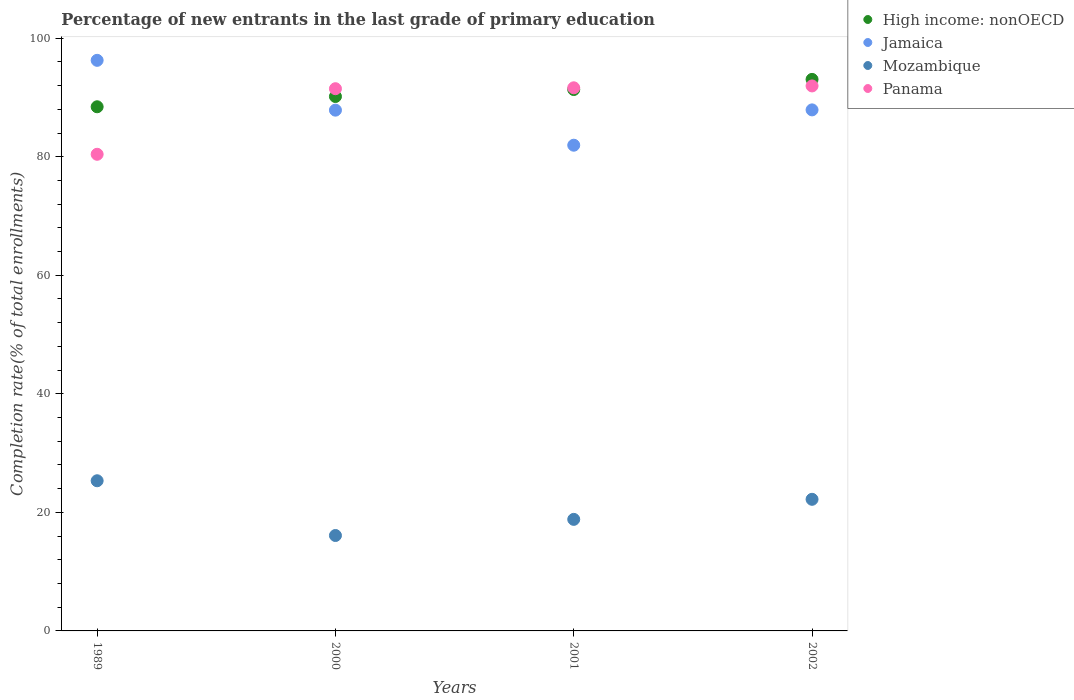How many different coloured dotlines are there?
Make the answer very short. 4. What is the percentage of new entrants in Panama in 1989?
Your response must be concise. 80.41. Across all years, what is the maximum percentage of new entrants in Mozambique?
Provide a short and direct response. 25.33. Across all years, what is the minimum percentage of new entrants in Mozambique?
Give a very brief answer. 16.1. In which year was the percentage of new entrants in High income: nonOECD maximum?
Your answer should be compact. 2002. In which year was the percentage of new entrants in Jamaica minimum?
Offer a very short reply. 2001. What is the total percentage of new entrants in High income: nonOECD in the graph?
Offer a very short reply. 362.98. What is the difference between the percentage of new entrants in Panama in 1989 and that in 2001?
Keep it short and to the point. -11.22. What is the difference between the percentage of new entrants in Panama in 1989 and the percentage of new entrants in Jamaica in 2000?
Your response must be concise. -7.45. What is the average percentage of new entrants in Panama per year?
Provide a succinct answer. 88.87. In the year 2000, what is the difference between the percentage of new entrants in Mozambique and percentage of new entrants in Jamaica?
Provide a short and direct response. -71.76. What is the ratio of the percentage of new entrants in Mozambique in 2001 to that in 2002?
Provide a short and direct response. 0.85. Is the percentage of new entrants in Panama in 2001 less than that in 2002?
Your answer should be compact. Yes. Is the difference between the percentage of new entrants in Mozambique in 2000 and 2002 greater than the difference between the percentage of new entrants in Jamaica in 2000 and 2002?
Your response must be concise. No. What is the difference between the highest and the second highest percentage of new entrants in Panama?
Give a very brief answer. 0.32. What is the difference between the highest and the lowest percentage of new entrants in Jamaica?
Keep it short and to the point. 14.32. In how many years, is the percentage of new entrants in Jamaica greater than the average percentage of new entrants in Jamaica taken over all years?
Ensure brevity in your answer.  1. Is it the case that in every year, the sum of the percentage of new entrants in High income: nonOECD and percentage of new entrants in Jamaica  is greater than the sum of percentage of new entrants in Panama and percentage of new entrants in Mozambique?
Your answer should be compact. No. Is it the case that in every year, the sum of the percentage of new entrants in Mozambique and percentage of new entrants in Jamaica  is greater than the percentage of new entrants in Panama?
Provide a short and direct response. Yes. Does the percentage of new entrants in High income: nonOECD monotonically increase over the years?
Your answer should be very brief. Yes. Is the percentage of new entrants in Mozambique strictly less than the percentage of new entrants in Panama over the years?
Provide a succinct answer. Yes. How many dotlines are there?
Your response must be concise. 4. How many years are there in the graph?
Provide a succinct answer. 4. Are the values on the major ticks of Y-axis written in scientific E-notation?
Offer a terse response. No. Where does the legend appear in the graph?
Offer a terse response. Top right. What is the title of the graph?
Offer a terse response. Percentage of new entrants in the last grade of primary education. What is the label or title of the Y-axis?
Provide a short and direct response. Completion rate(% of total enrollments). What is the Completion rate(% of total enrollments) of High income: nonOECD in 1989?
Your response must be concise. 88.43. What is the Completion rate(% of total enrollments) in Jamaica in 1989?
Provide a short and direct response. 96.26. What is the Completion rate(% of total enrollments) in Mozambique in 1989?
Your answer should be very brief. 25.33. What is the Completion rate(% of total enrollments) in Panama in 1989?
Your answer should be very brief. 80.41. What is the Completion rate(% of total enrollments) in High income: nonOECD in 2000?
Make the answer very short. 90.16. What is the Completion rate(% of total enrollments) of Jamaica in 2000?
Keep it short and to the point. 87.86. What is the Completion rate(% of total enrollments) in Mozambique in 2000?
Your response must be concise. 16.1. What is the Completion rate(% of total enrollments) of Panama in 2000?
Ensure brevity in your answer.  91.48. What is the Completion rate(% of total enrollments) of High income: nonOECD in 2001?
Your answer should be very brief. 91.34. What is the Completion rate(% of total enrollments) in Jamaica in 2001?
Your answer should be very brief. 81.95. What is the Completion rate(% of total enrollments) in Mozambique in 2001?
Make the answer very short. 18.82. What is the Completion rate(% of total enrollments) of Panama in 2001?
Provide a succinct answer. 91.63. What is the Completion rate(% of total enrollments) in High income: nonOECD in 2002?
Your answer should be very brief. 93.05. What is the Completion rate(% of total enrollments) in Jamaica in 2002?
Offer a very short reply. 87.91. What is the Completion rate(% of total enrollments) of Mozambique in 2002?
Offer a very short reply. 22.2. What is the Completion rate(% of total enrollments) of Panama in 2002?
Your answer should be compact. 91.95. Across all years, what is the maximum Completion rate(% of total enrollments) of High income: nonOECD?
Your answer should be compact. 93.05. Across all years, what is the maximum Completion rate(% of total enrollments) of Jamaica?
Provide a succinct answer. 96.26. Across all years, what is the maximum Completion rate(% of total enrollments) of Mozambique?
Provide a succinct answer. 25.33. Across all years, what is the maximum Completion rate(% of total enrollments) in Panama?
Your response must be concise. 91.95. Across all years, what is the minimum Completion rate(% of total enrollments) of High income: nonOECD?
Offer a terse response. 88.43. Across all years, what is the minimum Completion rate(% of total enrollments) in Jamaica?
Ensure brevity in your answer.  81.95. Across all years, what is the minimum Completion rate(% of total enrollments) of Mozambique?
Provide a succinct answer. 16.1. Across all years, what is the minimum Completion rate(% of total enrollments) of Panama?
Offer a terse response. 80.41. What is the total Completion rate(% of total enrollments) of High income: nonOECD in the graph?
Ensure brevity in your answer.  362.98. What is the total Completion rate(% of total enrollments) of Jamaica in the graph?
Give a very brief answer. 353.97. What is the total Completion rate(% of total enrollments) in Mozambique in the graph?
Offer a terse response. 82.46. What is the total Completion rate(% of total enrollments) in Panama in the graph?
Make the answer very short. 355.47. What is the difference between the Completion rate(% of total enrollments) of High income: nonOECD in 1989 and that in 2000?
Ensure brevity in your answer.  -1.73. What is the difference between the Completion rate(% of total enrollments) in Jamaica in 1989 and that in 2000?
Your answer should be compact. 8.4. What is the difference between the Completion rate(% of total enrollments) in Mozambique in 1989 and that in 2000?
Your answer should be very brief. 9.24. What is the difference between the Completion rate(% of total enrollments) of Panama in 1989 and that in 2000?
Your answer should be very brief. -11.06. What is the difference between the Completion rate(% of total enrollments) of High income: nonOECD in 1989 and that in 2001?
Offer a terse response. -2.91. What is the difference between the Completion rate(% of total enrollments) of Jamaica in 1989 and that in 2001?
Your response must be concise. 14.32. What is the difference between the Completion rate(% of total enrollments) of Mozambique in 1989 and that in 2001?
Offer a terse response. 6.51. What is the difference between the Completion rate(% of total enrollments) in Panama in 1989 and that in 2001?
Provide a succinct answer. -11.22. What is the difference between the Completion rate(% of total enrollments) of High income: nonOECD in 1989 and that in 2002?
Your answer should be compact. -4.62. What is the difference between the Completion rate(% of total enrollments) in Jamaica in 1989 and that in 2002?
Provide a succinct answer. 8.36. What is the difference between the Completion rate(% of total enrollments) in Mozambique in 1989 and that in 2002?
Offer a terse response. 3.13. What is the difference between the Completion rate(% of total enrollments) in Panama in 1989 and that in 2002?
Ensure brevity in your answer.  -11.53. What is the difference between the Completion rate(% of total enrollments) in High income: nonOECD in 2000 and that in 2001?
Offer a terse response. -1.18. What is the difference between the Completion rate(% of total enrollments) of Jamaica in 2000 and that in 2001?
Provide a short and direct response. 5.91. What is the difference between the Completion rate(% of total enrollments) of Mozambique in 2000 and that in 2001?
Provide a short and direct response. -2.72. What is the difference between the Completion rate(% of total enrollments) in Panama in 2000 and that in 2001?
Your response must be concise. -0.15. What is the difference between the Completion rate(% of total enrollments) of High income: nonOECD in 2000 and that in 2002?
Make the answer very short. -2.89. What is the difference between the Completion rate(% of total enrollments) in Jamaica in 2000 and that in 2002?
Your answer should be compact. -0.05. What is the difference between the Completion rate(% of total enrollments) of Mozambique in 2000 and that in 2002?
Provide a short and direct response. -6.11. What is the difference between the Completion rate(% of total enrollments) of Panama in 2000 and that in 2002?
Ensure brevity in your answer.  -0.47. What is the difference between the Completion rate(% of total enrollments) of High income: nonOECD in 2001 and that in 2002?
Give a very brief answer. -1.71. What is the difference between the Completion rate(% of total enrollments) of Jamaica in 2001 and that in 2002?
Your answer should be very brief. -5.96. What is the difference between the Completion rate(% of total enrollments) in Mozambique in 2001 and that in 2002?
Keep it short and to the point. -3.38. What is the difference between the Completion rate(% of total enrollments) of Panama in 2001 and that in 2002?
Provide a short and direct response. -0.32. What is the difference between the Completion rate(% of total enrollments) of High income: nonOECD in 1989 and the Completion rate(% of total enrollments) of Jamaica in 2000?
Provide a short and direct response. 0.57. What is the difference between the Completion rate(% of total enrollments) of High income: nonOECD in 1989 and the Completion rate(% of total enrollments) of Mozambique in 2000?
Make the answer very short. 72.33. What is the difference between the Completion rate(% of total enrollments) in High income: nonOECD in 1989 and the Completion rate(% of total enrollments) in Panama in 2000?
Give a very brief answer. -3.05. What is the difference between the Completion rate(% of total enrollments) of Jamaica in 1989 and the Completion rate(% of total enrollments) of Mozambique in 2000?
Provide a succinct answer. 80.17. What is the difference between the Completion rate(% of total enrollments) of Jamaica in 1989 and the Completion rate(% of total enrollments) of Panama in 2000?
Your answer should be very brief. 4.79. What is the difference between the Completion rate(% of total enrollments) in Mozambique in 1989 and the Completion rate(% of total enrollments) in Panama in 2000?
Your answer should be very brief. -66.14. What is the difference between the Completion rate(% of total enrollments) in High income: nonOECD in 1989 and the Completion rate(% of total enrollments) in Jamaica in 2001?
Your answer should be very brief. 6.48. What is the difference between the Completion rate(% of total enrollments) in High income: nonOECD in 1989 and the Completion rate(% of total enrollments) in Mozambique in 2001?
Offer a very short reply. 69.61. What is the difference between the Completion rate(% of total enrollments) in High income: nonOECD in 1989 and the Completion rate(% of total enrollments) in Panama in 2001?
Provide a short and direct response. -3.2. What is the difference between the Completion rate(% of total enrollments) of Jamaica in 1989 and the Completion rate(% of total enrollments) of Mozambique in 2001?
Provide a short and direct response. 77.45. What is the difference between the Completion rate(% of total enrollments) of Jamaica in 1989 and the Completion rate(% of total enrollments) of Panama in 2001?
Your answer should be very brief. 4.63. What is the difference between the Completion rate(% of total enrollments) of Mozambique in 1989 and the Completion rate(% of total enrollments) of Panama in 2001?
Ensure brevity in your answer.  -66.3. What is the difference between the Completion rate(% of total enrollments) in High income: nonOECD in 1989 and the Completion rate(% of total enrollments) in Jamaica in 2002?
Keep it short and to the point. 0.52. What is the difference between the Completion rate(% of total enrollments) of High income: nonOECD in 1989 and the Completion rate(% of total enrollments) of Mozambique in 2002?
Your answer should be compact. 66.23. What is the difference between the Completion rate(% of total enrollments) in High income: nonOECD in 1989 and the Completion rate(% of total enrollments) in Panama in 2002?
Give a very brief answer. -3.52. What is the difference between the Completion rate(% of total enrollments) of Jamaica in 1989 and the Completion rate(% of total enrollments) of Mozambique in 2002?
Keep it short and to the point. 74.06. What is the difference between the Completion rate(% of total enrollments) in Jamaica in 1989 and the Completion rate(% of total enrollments) in Panama in 2002?
Your answer should be very brief. 4.32. What is the difference between the Completion rate(% of total enrollments) of Mozambique in 1989 and the Completion rate(% of total enrollments) of Panama in 2002?
Keep it short and to the point. -66.61. What is the difference between the Completion rate(% of total enrollments) in High income: nonOECD in 2000 and the Completion rate(% of total enrollments) in Jamaica in 2001?
Your answer should be very brief. 8.22. What is the difference between the Completion rate(% of total enrollments) in High income: nonOECD in 2000 and the Completion rate(% of total enrollments) in Mozambique in 2001?
Offer a terse response. 71.34. What is the difference between the Completion rate(% of total enrollments) in High income: nonOECD in 2000 and the Completion rate(% of total enrollments) in Panama in 2001?
Give a very brief answer. -1.47. What is the difference between the Completion rate(% of total enrollments) in Jamaica in 2000 and the Completion rate(% of total enrollments) in Mozambique in 2001?
Your answer should be very brief. 69.04. What is the difference between the Completion rate(% of total enrollments) in Jamaica in 2000 and the Completion rate(% of total enrollments) in Panama in 2001?
Provide a succinct answer. -3.77. What is the difference between the Completion rate(% of total enrollments) of Mozambique in 2000 and the Completion rate(% of total enrollments) of Panama in 2001?
Keep it short and to the point. -75.53. What is the difference between the Completion rate(% of total enrollments) in High income: nonOECD in 2000 and the Completion rate(% of total enrollments) in Jamaica in 2002?
Your answer should be very brief. 2.26. What is the difference between the Completion rate(% of total enrollments) in High income: nonOECD in 2000 and the Completion rate(% of total enrollments) in Mozambique in 2002?
Offer a terse response. 67.96. What is the difference between the Completion rate(% of total enrollments) of High income: nonOECD in 2000 and the Completion rate(% of total enrollments) of Panama in 2002?
Make the answer very short. -1.78. What is the difference between the Completion rate(% of total enrollments) of Jamaica in 2000 and the Completion rate(% of total enrollments) of Mozambique in 2002?
Your answer should be compact. 65.66. What is the difference between the Completion rate(% of total enrollments) of Jamaica in 2000 and the Completion rate(% of total enrollments) of Panama in 2002?
Provide a succinct answer. -4.09. What is the difference between the Completion rate(% of total enrollments) in Mozambique in 2000 and the Completion rate(% of total enrollments) in Panama in 2002?
Offer a terse response. -75.85. What is the difference between the Completion rate(% of total enrollments) in High income: nonOECD in 2001 and the Completion rate(% of total enrollments) in Jamaica in 2002?
Provide a succinct answer. 3.43. What is the difference between the Completion rate(% of total enrollments) of High income: nonOECD in 2001 and the Completion rate(% of total enrollments) of Mozambique in 2002?
Give a very brief answer. 69.13. What is the difference between the Completion rate(% of total enrollments) of High income: nonOECD in 2001 and the Completion rate(% of total enrollments) of Panama in 2002?
Your response must be concise. -0.61. What is the difference between the Completion rate(% of total enrollments) of Jamaica in 2001 and the Completion rate(% of total enrollments) of Mozambique in 2002?
Your answer should be compact. 59.74. What is the difference between the Completion rate(% of total enrollments) in Jamaica in 2001 and the Completion rate(% of total enrollments) in Panama in 2002?
Your answer should be compact. -10. What is the difference between the Completion rate(% of total enrollments) in Mozambique in 2001 and the Completion rate(% of total enrollments) in Panama in 2002?
Your response must be concise. -73.13. What is the average Completion rate(% of total enrollments) in High income: nonOECD per year?
Provide a short and direct response. 90.74. What is the average Completion rate(% of total enrollments) in Jamaica per year?
Offer a very short reply. 88.49. What is the average Completion rate(% of total enrollments) of Mozambique per year?
Provide a succinct answer. 20.61. What is the average Completion rate(% of total enrollments) of Panama per year?
Offer a very short reply. 88.87. In the year 1989, what is the difference between the Completion rate(% of total enrollments) of High income: nonOECD and Completion rate(% of total enrollments) of Jamaica?
Your answer should be very brief. -7.84. In the year 1989, what is the difference between the Completion rate(% of total enrollments) of High income: nonOECD and Completion rate(% of total enrollments) of Mozambique?
Your answer should be very brief. 63.09. In the year 1989, what is the difference between the Completion rate(% of total enrollments) of High income: nonOECD and Completion rate(% of total enrollments) of Panama?
Your response must be concise. 8.02. In the year 1989, what is the difference between the Completion rate(% of total enrollments) of Jamaica and Completion rate(% of total enrollments) of Mozambique?
Keep it short and to the point. 70.93. In the year 1989, what is the difference between the Completion rate(% of total enrollments) in Jamaica and Completion rate(% of total enrollments) in Panama?
Your response must be concise. 15.85. In the year 1989, what is the difference between the Completion rate(% of total enrollments) in Mozambique and Completion rate(% of total enrollments) in Panama?
Offer a very short reply. -55.08. In the year 2000, what is the difference between the Completion rate(% of total enrollments) in High income: nonOECD and Completion rate(% of total enrollments) in Jamaica?
Keep it short and to the point. 2.3. In the year 2000, what is the difference between the Completion rate(% of total enrollments) in High income: nonOECD and Completion rate(% of total enrollments) in Mozambique?
Offer a very short reply. 74.06. In the year 2000, what is the difference between the Completion rate(% of total enrollments) in High income: nonOECD and Completion rate(% of total enrollments) in Panama?
Offer a very short reply. -1.32. In the year 2000, what is the difference between the Completion rate(% of total enrollments) of Jamaica and Completion rate(% of total enrollments) of Mozambique?
Make the answer very short. 71.76. In the year 2000, what is the difference between the Completion rate(% of total enrollments) of Jamaica and Completion rate(% of total enrollments) of Panama?
Give a very brief answer. -3.62. In the year 2000, what is the difference between the Completion rate(% of total enrollments) in Mozambique and Completion rate(% of total enrollments) in Panama?
Offer a terse response. -75.38. In the year 2001, what is the difference between the Completion rate(% of total enrollments) of High income: nonOECD and Completion rate(% of total enrollments) of Jamaica?
Make the answer very short. 9.39. In the year 2001, what is the difference between the Completion rate(% of total enrollments) in High income: nonOECD and Completion rate(% of total enrollments) in Mozambique?
Provide a short and direct response. 72.52. In the year 2001, what is the difference between the Completion rate(% of total enrollments) of High income: nonOECD and Completion rate(% of total enrollments) of Panama?
Ensure brevity in your answer.  -0.29. In the year 2001, what is the difference between the Completion rate(% of total enrollments) in Jamaica and Completion rate(% of total enrollments) in Mozambique?
Give a very brief answer. 63.13. In the year 2001, what is the difference between the Completion rate(% of total enrollments) in Jamaica and Completion rate(% of total enrollments) in Panama?
Your response must be concise. -9.69. In the year 2001, what is the difference between the Completion rate(% of total enrollments) in Mozambique and Completion rate(% of total enrollments) in Panama?
Ensure brevity in your answer.  -72.81. In the year 2002, what is the difference between the Completion rate(% of total enrollments) of High income: nonOECD and Completion rate(% of total enrollments) of Jamaica?
Make the answer very short. 5.14. In the year 2002, what is the difference between the Completion rate(% of total enrollments) of High income: nonOECD and Completion rate(% of total enrollments) of Mozambique?
Provide a short and direct response. 70.84. In the year 2002, what is the difference between the Completion rate(% of total enrollments) of High income: nonOECD and Completion rate(% of total enrollments) of Panama?
Provide a succinct answer. 1.1. In the year 2002, what is the difference between the Completion rate(% of total enrollments) in Jamaica and Completion rate(% of total enrollments) in Mozambique?
Keep it short and to the point. 65.7. In the year 2002, what is the difference between the Completion rate(% of total enrollments) in Jamaica and Completion rate(% of total enrollments) in Panama?
Give a very brief answer. -4.04. In the year 2002, what is the difference between the Completion rate(% of total enrollments) in Mozambique and Completion rate(% of total enrollments) in Panama?
Provide a succinct answer. -69.74. What is the ratio of the Completion rate(% of total enrollments) in High income: nonOECD in 1989 to that in 2000?
Your answer should be compact. 0.98. What is the ratio of the Completion rate(% of total enrollments) of Jamaica in 1989 to that in 2000?
Provide a succinct answer. 1.1. What is the ratio of the Completion rate(% of total enrollments) in Mozambique in 1989 to that in 2000?
Offer a terse response. 1.57. What is the ratio of the Completion rate(% of total enrollments) of Panama in 1989 to that in 2000?
Keep it short and to the point. 0.88. What is the ratio of the Completion rate(% of total enrollments) in High income: nonOECD in 1989 to that in 2001?
Provide a succinct answer. 0.97. What is the ratio of the Completion rate(% of total enrollments) of Jamaica in 1989 to that in 2001?
Provide a short and direct response. 1.17. What is the ratio of the Completion rate(% of total enrollments) in Mozambique in 1989 to that in 2001?
Provide a short and direct response. 1.35. What is the ratio of the Completion rate(% of total enrollments) of Panama in 1989 to that in 2001?
Give a very brief answer. 0.88. What is the ratio of the Completion rate(% of total enrollments) of High income: nonOECD in 1989 to that in 2002?
Your answer should be very brief. 0.95. What is the ratio of the Completion rate(% of total enrollments) in Jamaica in 1989 to that in 2002?
Give a very brief answer. 1.1. What is the ratio of the Completion rate(% of total enrollments) in Mozambique in 1989 to that in 2002?
Your response must be concise. 1.14. What is the ratio of the Completion rate(% of total enrollments) in Panama in 1989 to that in 2002?
Ensure brevity in your answer.  0.87. What is the ratio of the Completion rate(% of total enrollments) in High income: nonOECD in 2000 to that in 2001?
Make the answer very short. 0.99. What is the ratio of the Completion rate(% of total enrollments) of Jamaica in 2000 to that in 2001?
Ensure brevity in your answer.  1.07. What is the ratio of the Completion rate(% of total enrollments) of Mozambique in 2000 to that in 2001?
Provide a short and direct response. 0.86. What is the ratio of the Completion rate(% of total enrollments) in Mozambique in 2000 to that in 2002?
Keep it short and to the point. 0.72. What is the ratio of the Completion rate(% of total enrollments) in High income: nonOECD in 2001 to that in 2002?
Provide a short and direct response. 0.98. What is the ratio of the Completion rate(% of total enrollments) of Jamaica in 2001 to that in 2002?
Provide a short and direct response. 0.93. What is the ratio of the Completion rate(% of total enrollments) in Mozambique in 2001 to that in 2002?
Keep it short and to the point. 0.85. What is the difference between the highest and the second highest Completion rate(% of total enrollments) in High income: nonOECD?
Give a very brief answer. 1.71. What is the difference between the highest and the second highest Completion rate(% of total enrollments) in Jamaica?
Keep it short and to the point. 8.36. What is the difference between the highest and the second highest Completion rate(% of total enrollments) of Mozambique?
Your response must be concise. 3.13. What is the difference between the highest and the second highest Completion rate(% of total enrollments) in Panama?
Your answer should be compact. 0.32. What is the difference between the highest and the lowest Completion rate(% of total enrollments) of High income: nonOECD?
Your response must be concise. 4.62. What is the difference between the highest and the lowest Completion rate(% of total enrollments) of Jamaica?
Provide a short and direct response. 14.32. What is the difference between the highest and the lowest Completion rate(% of total enrollments) of Mozambique?
Give a very brief answer. 9.24. What is the difference between the highest and the lowest Completion rate(% of total enrollments) in Panama?
Your answer should be compact. 11.53. 